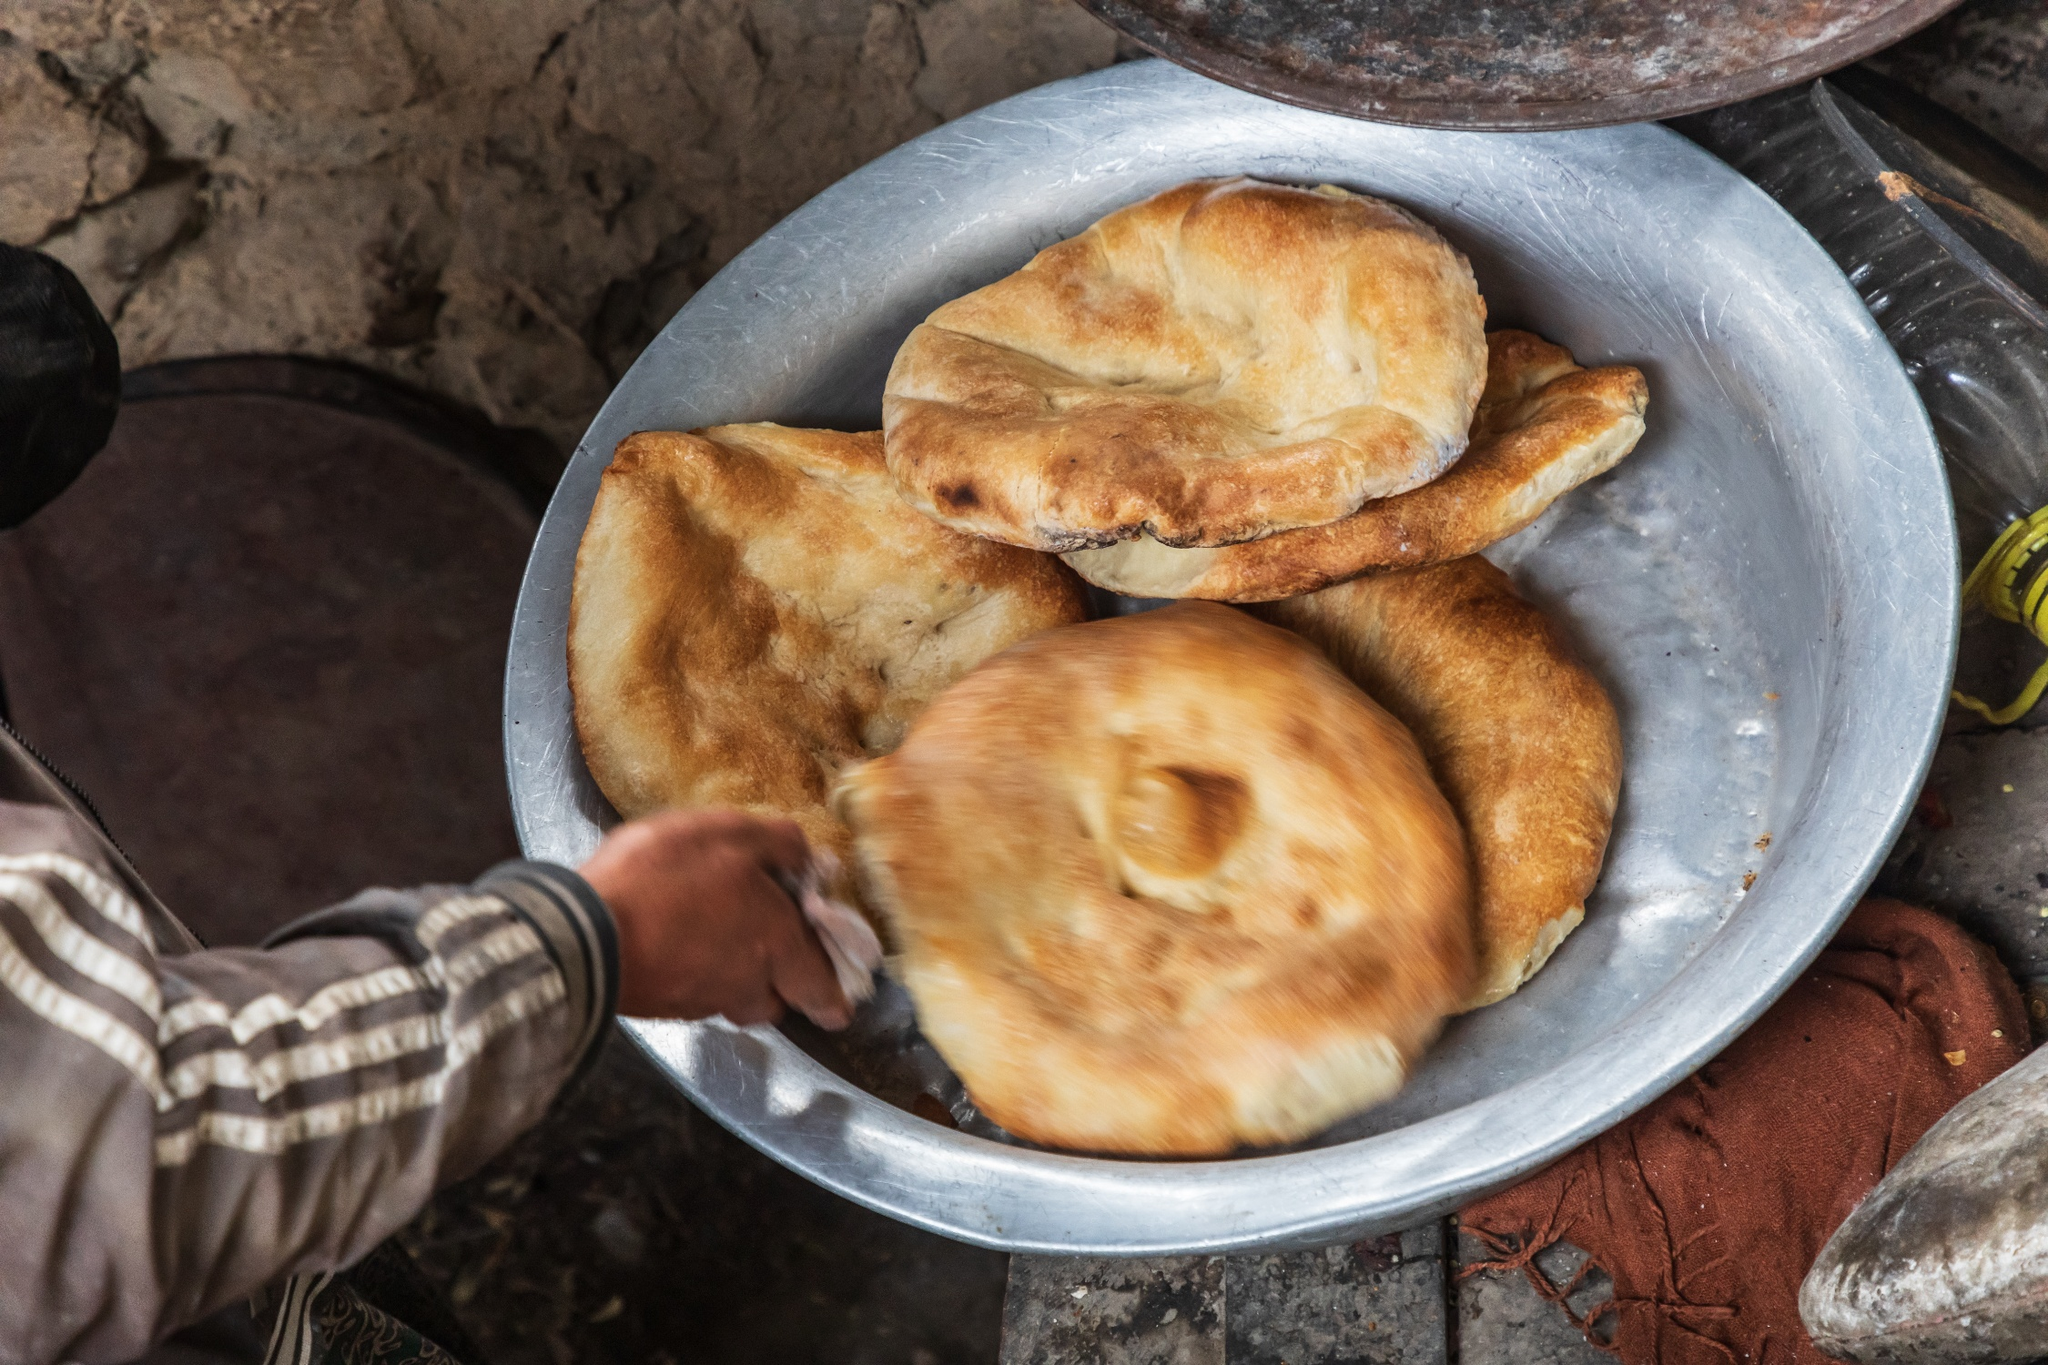Can you elaborate on the techniques used to photograph this image? This image uses several photographic techniques to create its compelling composition. The focus is primarily on the metal plate and the bread, achieved through a shallow depth of field, which blurs the background and draws attention to the main subjects. The angle of the shot, taken from slightly above, gives a clear view of the bread and the action of the hand. The lighting is natural and soft, enhancing the golden tones of the bread and providing a real-life, unprocessed feeling. The textures of the bread and the metal plate are captured vividly, adding to the image's tangible and rustic ambiance. How does the arrangement of objects in the image contribute to its composition? The arrangement of objects in the image significantly contributes to its balanced and harmonious composition. The bread is centrally placed on the metal plate, creating a focal point that immediately draws the viewer's eye. The hand entering the frame from the left adds a dynamic element, suggesting movement and activity. The slightly blurred background with the oil bottle adds context without distracting from the main subjects. Together, the objects form a cohesive scene that tells a story and engages the viewer. Let your imagination run wild and tell me what this image could represent in a fantastical world. In the mystical land of Eldoria, where enchanted forests meet ancient, talking mountains, this image depicts the sacred ceremony of bread-blessing by the Woodland Guardians. Here, bread is not merely a food item but a magical artifact imbued with the life force of the ancient trees. Every year, during the Harvest Moon Festival, a chosen Guardian, marked by an enchanted sleeve of Striped Oak, arranges the golden Elven bread onto the Celestial Plate of Harmony. The bread, known for its legendary ability to heal wounds and grant visions, is blessed with the Light of the Evening Star, embodied by the oil of the Stellar Fern kept in magical bottles. This sacred offering, glowing with a soft, ethereal light, is then shared with the beings of Eldoria, ensuring peace, prosperity, and an unbroken bond with nature’s magic. Please provide a detailed description of a realistic setting where this image might be taken. This image is likely taken in a rustic kitchen within a quaint, rural home. The setting could be found in a small village where traditional methods of bread-making are still cherished. The kitchen has earthy tones and a simple layout, with rough stone walls that evoke a sense of history and timelessness. Sitting on a rough-hewn wooden table is the large metal plate holding the freshly baked bread, crafted in a wood-fired oven that imparts a distinctive, fragrant aroma. An old bottle of oil, placed nearby, reflects the practicality of the setting and the importance of homemade cooking. The hand in the striped sleeve suggests a moment of rich, daily tradition, perhaps a grandmother or elder passing down culinary skills to the next generation. This evocative scene is a testament to the enduring charm and comfort of rural life. What kind of meal might follow the preparation seen in this image? Following the preparation seen in this image, the meal might be a hearty and simple affair, reflecting the rustic charm of the setting. Freshly baked bread would be the centerpiece, possibly accompanied by locally produced cheese, olives, and a variety of dips such as homemade hummus or a tangy tomato spread. There could be a flavorful soup or stew made with fresh vegetables and meat or lentils, simmered over a slow fire. A salad of garden greens, seasoned with herbs and a drizzle of the oil seen in the image, might provide a refreshing contrast. Finally, the meal could end with a sweet treat like freshly cut fruit or a traditional dessert, ensuring that the family enjoys a wholesome and satisfying dining experience together. 